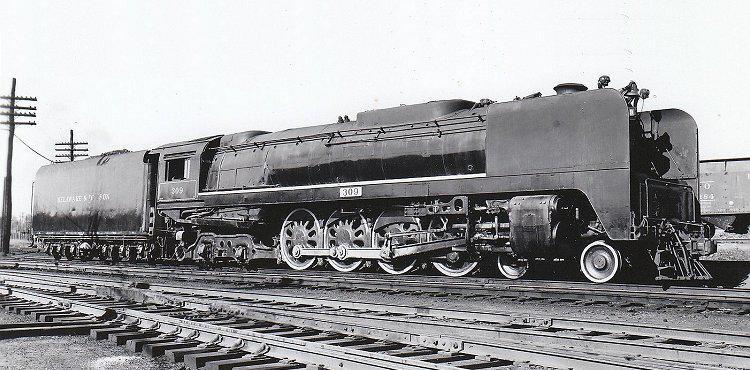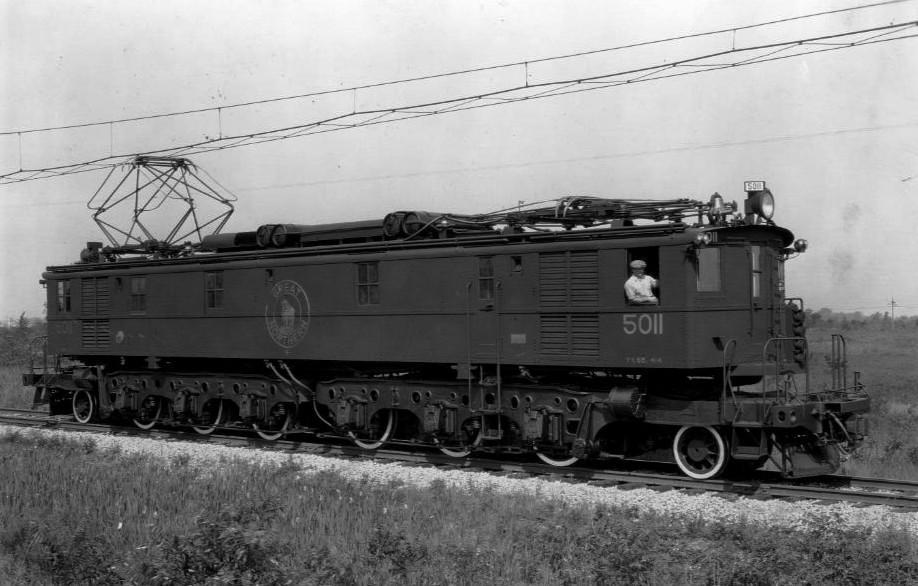The first image is the image on the left, the second image is the image on the right. Examine the images to the left and right. Is the description "All trains are heading to the right." accurate? Answer yes or no. Yes. The first image is the image on the left, the second image is the image on the right. Assess this claim about the two images: "An image shows a train with a rounded front and a stripe that curves up from the bottom of the front to run along the side, and geometric 3D frames are above the train.". Correct or not? Answer yes or no. No. 